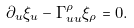<formula> <loc_0><loc_0><loc_500><loc_500>\partial _ { u } \xi _ { u } - \Gamma _ { u u } ^ { \rho } \xi _ { \rho } = 0 .</formula> 